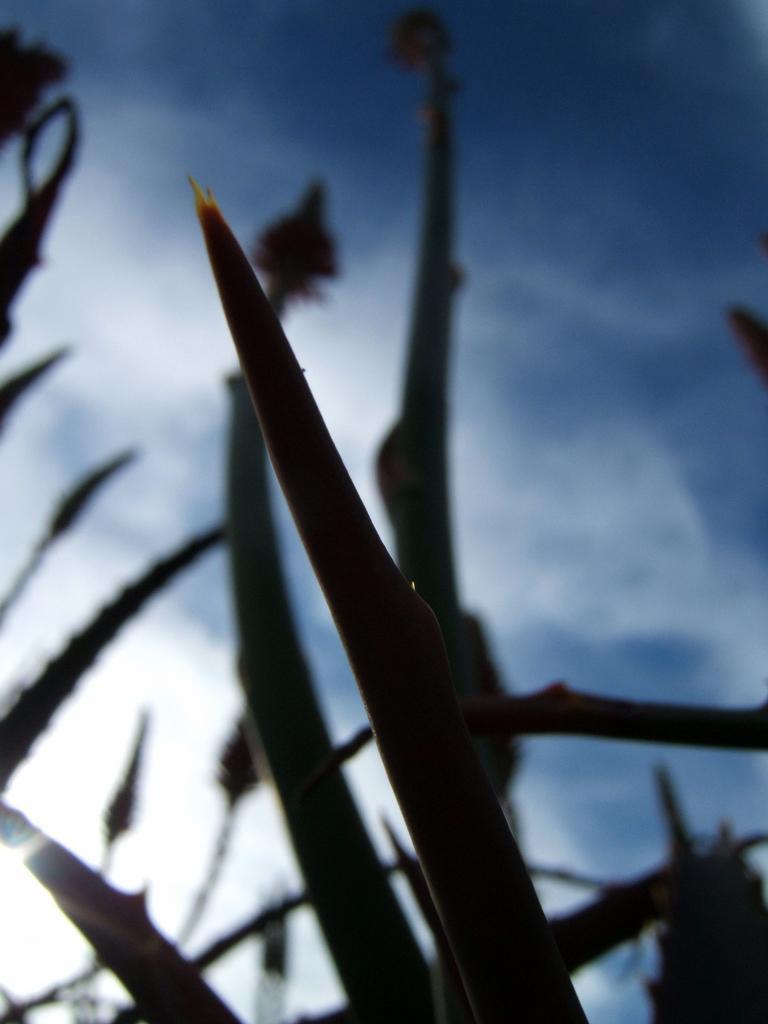Describe this image in one or two sentences. This image is slightly blurred, where we can see the plants and in the background, we can see the blue color sky. 